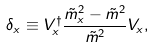Convert formula to latex. <formula><loc_0><loc_0><loc_500><loc_500>\delta _ { x } \equiv V _ { x } ^ { \dagger } \frac { \tilde { m } ^ { 2 } _ { x } - \tilde { m } ^ { 2 } } { \tilde { m } ^ { 2 } } V _ { x } ,</formula> 